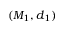<formula> <loc_0><loc_0><loc_500><loc_500>( M _ { 1 } , d _ { 1 } )</formula> 